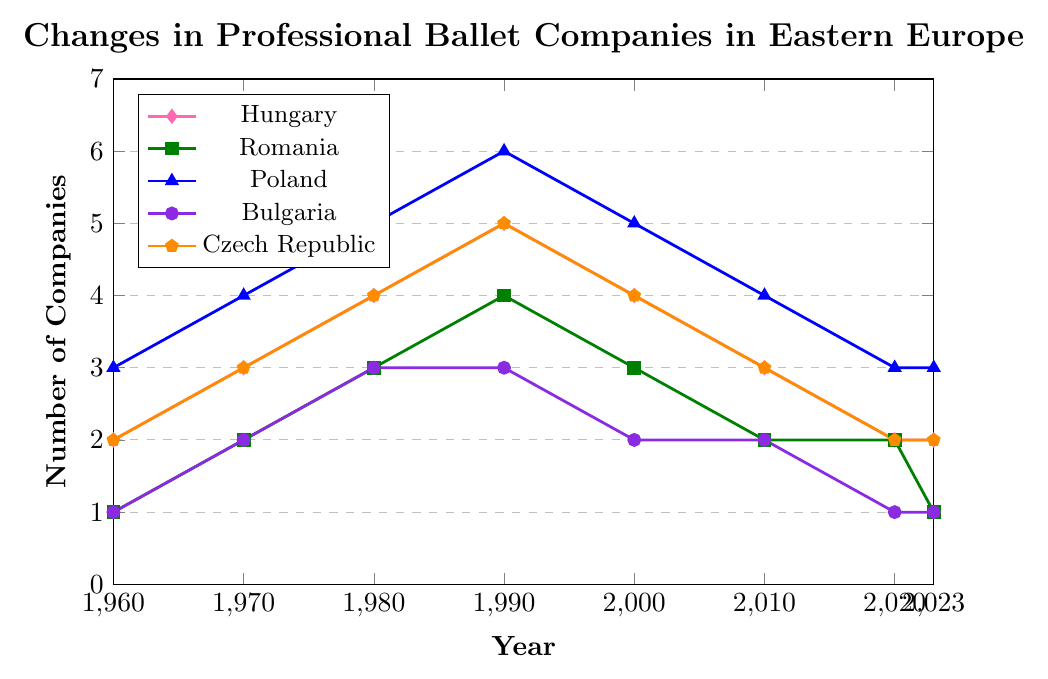What country experienced the highest peak in the number of professional ballet companies, and what was the number? To determine which country had the highest peak, observe the maximum y-values across all lines. Identify the highest point, which is Poland at 6 ballet companies in 1990.
Answer: Poland, 6 Which country had the largest decline in the number of companies from 1990 to 2023? Compare the changes in y-values for each country between 1990 and 2023. Hungary fell from 5 to 2, Romania from 4 to 1, Poland from 6 to 3, Bulgaria from 3 to 1, and the Czech Republic from 5 to 2. The largest decline is Romania, falling 3.
Answer: Romania, 3 How many professional ballet companies were there in total across all five countries in 1980? Sum the number of ballet companies in 1980: Hungary (4), Romania (3), Poland (5), Bulgaria (3), Czech Republic (4). 4 + 3 + 5 + 3 + 4 = 19.
Answer: 19 Which country's trend shows the least change in the number of ballet companies from 1960 to 2023? Evaluate the overall change by comparing the start and end values for each country: Hungary (2 to 2), Romania (1 to 1), Poland (3 to 3), Bulgaria (1 to 1), Czech Republic (2 to 2). Both Hungary, Romania, and the Czech Republic show a change of 0, but Romania experiences intermediate changes, thus the least variable is Hungary.
Answer: Hungary What's the difference in the number of ballet companies between Poland and Bulgaria in 2023? Find the y-values for Poland and Bulgaria in 2023 and subtract them: Poland (3) - Bulgaria (1).
Answer: 2 What is the average number of ballet companies in Hungary over the entire period? Sum Hungary’s data points from all years: 2 + 3 + 4 + 5 + 4 + 3 + 2 + 2 = 25. Divide by total number of points (8): 25/8.
Answer: 3.125 During which decade did the Czech Republic see its largest increase in the number of companies? Compare the increment in each decade: 
1960-1970: +1 (2 to 3),
1970-1980: +1 (3 to 4),
1980-1990: +1 (4 to 5).
The largest increase is from 1960 to 1970, 1970 to 1980, and 1980 to 1990, all equal at 1.
Answer: 1960s, 1970s, 1980s How many more companies were there in Poland compared to Romania in 2010? Check the y-values for both countries in 2010 and subtract: Poland (4) - Romania (2).
Answer: 2 What is the average decline per decade in professional ballet companies in Bulgaria from 1990 to 2023? Calculate the total decline from 1990 (3) to 2023 (1): 3 - 1 = 2. There are three decades involved: 1990s, 2000s, 2010s, thus the average decline per decade is 2/3.
Answer: 0.67 